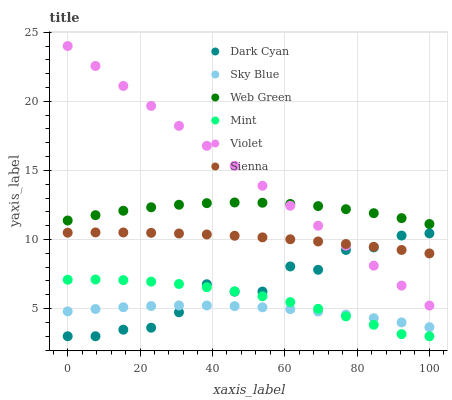Does Sky Blue have the minimum area under the curve?
Answer yes or no. Yes. Does Violet have the maximum area under the curve?
Answer yes or no. Yes. Does Sienna have the minimum area under the curve?
Answer yes or no. No. Does Sienna have the maximum area under the curve?
Answer yes or no. No. Is Violet the smoothest?
Answer yes or no. Yes. Is Dark Cyan the roughest?
Answer yes or no. Yes. Is Sienna the smoothest?
Answer yes or no. No. Is Sienna the roughest?
Answer yes or no. No. Does Dark Cyan have the lowest value?
Answer yes or no. Yes. Does Sienna have the lowest value?
Answer yes or no. No. Does Violet have the highest value?
Answer yes or no. Yes. Does Sienna have the highest value?
Answer yes or no. No. Is Sienna less than Web Green?
Answer yes or no. Yes. Is Violet greater than Sky Blue?
Answer yes or no. Yes. Does Dark Cyan intersect Sky Blue?
Answer yes or no. Yes. Is Dark Cyan less than Sky Blue?
Answer yes or no. No. Is Dark Cyan greater than Sky Blue?
Answer yes or no. No. Does Sienna intersect Web Green?
Answer yes or no. No. 